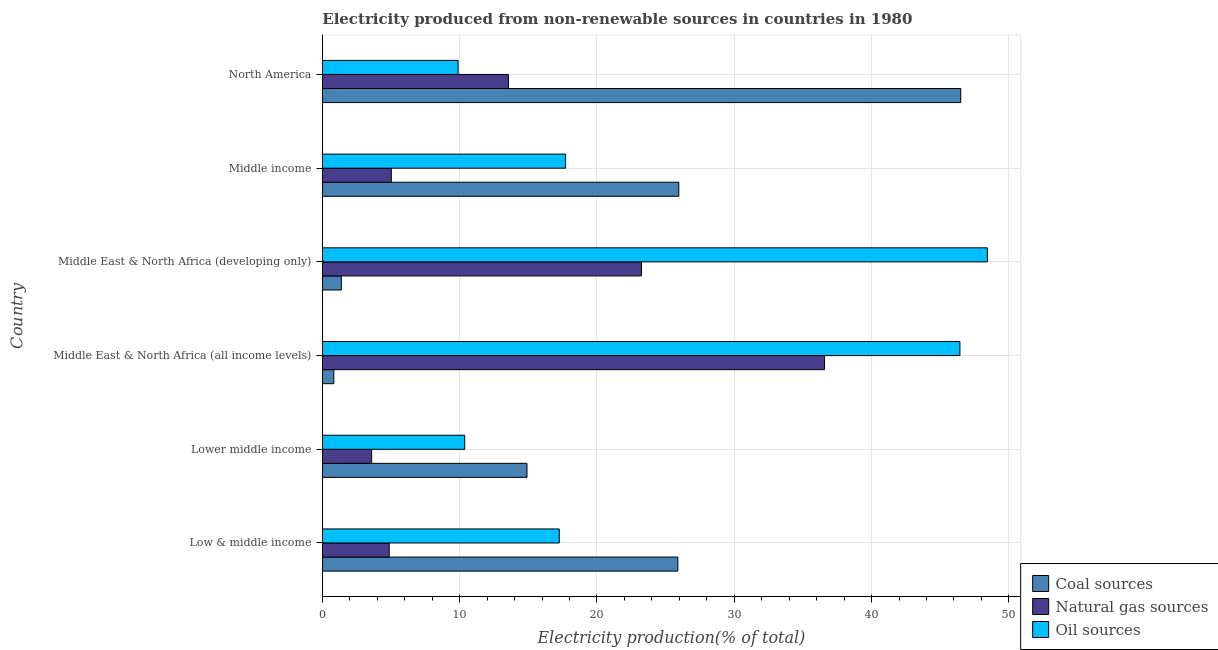How many different coloured bars are there?
Offer a very short reply. 3. Are the number of bars on each tick of the Y-axis equal?
Your response must be concise. Yes. How many bars are there on the 4th tick from the bottom?
Make the answer very short. 3. What is the label of the 6th group of bars from the top?
Give a very brief answer. Low & middle income. In how many cases, is the number of bars for a given country not equal to the number of legend labels?
Offer a terse response. 0. What is the percentage of electricity produced by natural gas in Middle East & North Africa (all income levels)?
Your answer should be very brief. 36.58. Across all countries, what is the maximum percentage of electricity produced by natural gas?
Offer a very short reply. 36.58. Across all countries, what is the minimum percentage of electricity produced by oil sources?
Make the answer very short. 9.89. In which country was the percentage of electricity produced by natural gas maximum?
Make the answer very short. Middle East & North Africa (all income levels). What is the total percentage of electricity produced by coal in the graph?
Your answer should be compact. 115.48. What is the difference between the percentage of electricity produced by coal in Middle East & North Africa (all income levels) and that in Middle income?
Ensure brevity in your answer.  -25.12. What is the difference between the percentage of electricity produced by natural gas in Middle income and the percentage of electricity produced by coal in Lower middle income?
Your answer should be very brief. -9.88. What is the average percentage of electricity produced by natural gas per country?
Your response must be concise. 14.48. What is the difference between the percentage of electricity produced by natural gas and percentage of electricity produced by oil sources in North America?
Keep it short and to the point. 3.66. What is the ratio of the percentage of electricity produced by natural gas in Lower middle income to that in Middle East & North Africa (developing only)?
Provide a short and direct response. 0.15. What is the difference between the highest and the second highest percentage of electricity produced by oil sources?
Your response must be concise. 2. What is the difference between the highest and the lowest percentage of electricity produced by natural gas?
Give a very brief answer. 32.98. Is the sum of the percentage of electricity produced by natural gas in Low & middle income and North America greater than the maximum percentage of electricity produced by coal across all countries?
Give a very brief answer. No. What does the 3rd bar from the top in Lower middle income represents?
Give a very brief answer. Coal sources. What does the 2nd bar from the bottom in Middle East & North Africa (developing only) represents?
Provide a succinct answer. Natural gas sources. Are all the bars in the graph horizontal?
Keep it short and to the point. Yes. How many countries are there in the graph?
Your answer should be compact. 6. Are the values on the major ticks of X-axis written in scientific E-notation?
Your answer should be very brief. No. Does the graph contain grids?
Offer a terse response. Yes. Where does the legend appear in the graph?
Your response must be concise. Bottom right. How many legend labels are there?
Your answer should be compact. 3. How are the legend labels stacked?
Provide a succinct answer. Vertical. What is the title of the graph?
Offer a terse response. Electricity produced from non-renewable sources in countries in 1980. Does "Coal" appear as one of the legend labels in the graph?
Offer a terse response. No. What is the Electricity production(% of total) in Coal sources in Low & middle income?
Provide a succinct answer. 25.89. What is the Electricity production(% of total) of Natural gas sources in Low & middle income?
Make the answer very short. 4.87. What is the Electricity production(% of total) of Oil sources in Low & middle income?
Offer a terse response. 17.26. What is the Electricity production(% of total) of Coal sources in Lower middle income?
Make the answer very short. 14.9. What is the Electricity production(% of total) in Natural gas sources in Lower middle income?
Provide a succinct answer. 3.59. What is the Electricity production(% of total) of Oil sources in Lower middle income?
Provide a succinct answer. 10.37. What is the Electricity production(% of total) in Coal sources in Middle East & North Africa (all income levels)?
Your answer should be very brief. 0.84. What is the Electricity production(% of total) of Natural gas sources in Middle East & North Africa (all income levels)?
Your answer should be compact. 36.58. What is the Electricity production(% of total) in Oil sources in Middle East & North Africa (all income levels)?
Your answer should be very brief. 46.43. What is the Electricity production(% of total) in Coal sources in Middle East & North Africa (developing only)?
Ensure brevity in your answer.  1.39. What is the Electricity production(% of total) in Natural gas sources in Middle East & North Africa (developing only)?
Keep it short and to the point. 23.24. What is the Electricity production(% of total) in Oil sources in Middle East & North Africa (developing only)?
Keep it short and to the point. 48.44. What is the Electricity production(% of total) of Coal sources in Middle income?
Offer a very short reply. 25.96. What is the Electricity production(% of total) in Natural gas sources in Middle income?
Offer a terse response. 5.02. What is the Electricity production(% of total) in Oil sources in Middle income?
Your answer should be compact. 17.72. What is the Electricity production(% of total) in Coal sources in North America?
Provide a succinct answer. 46.49. What is the Electricity production(% of total) of Natural gas sources in North America?
Provide a short and direct response. 13.55. What is the Electricity production(% of total) in Oil sources in North America?
Offer a very short reply. 9.89. Across all countries, what is the maximum Electricity production(% of total) in Coal sources?
Provide a succinct answer. 46.49. Across all countries, what is the maximum Electricity production(% of total) in Natural gas sources?
Your response must be concise. 36.58. Across all countries, what is the maximum Electricity production(% of total) in Oil sources?
Offer a very short reply. 48.44. Across all countries, what is the minimum Electricity production(% of total) in Coal sources?
Make the answer very short. 0.84. Across all countries, what is the minimum Electricity production(% of total) in Natural gas sources?
Give a very brief answer. 3.59. Across all countries, what is the minimum Electricity production(% of total) of Oil sources?
Offer a very short reply. 9.89. What is the total Electricity production(% of total) in Coal sources in the graph?
Keep it short and to the point. 115.48. What is the total Electricity production(% of total) of Natural gas sources in the graph?
Keep it short and to the point. 86.85. What is the total Electricity production(% of total) of Oil sources in the graph?
Your response must be concise. 150.1. What is the difference between the Electricity production(% of total) in Coal sources in Low & middle income and that in Lower middle income?
Give a very brief answer. 10.99. What is the difference between the Electricity production(% of total) of Natural gas sources in Low & middle income and that in Lower middle income?
Your response must be concise. 1.28. What is the difference between the Electricity production(% of total) in Oil sources in Low & middle income and that in Lower middle income?
Your answer should be very brief. 6.89. What is the difference between the Electricity production(% of total) in Coal sources in Low & middle income and that in Middle East & North Africa (all income levels)?
Give a very brief answer. 25.05. What is the difference between the Electricity production(% of total) of Natural gas sources in Low & middle income and that in Middle East & North Africa (all income levels)?
Offer a very short reply. -31.71. What is the difference between the Electricity production(% of total) in Oil sources in Low & middle income and that in Middle East & North Africa (all income levels)?
Your answer should be compact. -29.18. What is the difference between the Electricity production(% of total) of Coal sources in Low & middle income and that in Middle East & North Africa (developing only)?
Give a very brief answer. 24.51. What is the difference between the Electricity production(% of total) of Natural gas sources in Low & middle income and that in Middle East & North Africa (developing only)?
Keep it short and to the point. -18.37. What is the difference between the Electricity production(% of total) of Oil sources in Low & middle income and that in Middle East & North Africa (developing only)?
Offer a terse response. -31.18. What is the difference between the Electricity production(% of total) in Coal sources in Low & middle income and that in Middle income?
Your answer should be compact. -0.07. What is the difference between the Electricity production(% of total) of Natural gas sources in Low & middle income and that in Middle income?
Provide a short and direct response. -0.15. What is the difference between the Electricity production(% of total) of Oil sources in Low & middle income and that in Middle income?
Offer a very short reply. -0.46. What is the difference between the Electricity production(% of total) in Coal sources in Low & middle income and that in North America?
Ensure brevity in your answer.  -20.6. What is the difference between the Electricity production(% of total) of Natural gas sources in Low & middle income and that in North America?
Offer a very short reply. -8.68. What is the difference between the Electricity production(% of total) in Oil sources in Low & middle income and that in North America?
Give a very brief answer. 7.37. What is the difference between the Electricity production(% of total) of Coal sources in Lower middle income and that in Middle East & North Africa (all income levels)?
Offer a very short reply. 14.07. What is the difference between the Electricity production(% of total) of Natural gas sources in Lower middle income and that in Middle East & North Africa (all income levels)?
Your answer should be compact. -32.98. What is the difference between the Electricity production(% of total) in Oil sources in Lower middle income and that in Middle East & North Africa (all income levels)?
Provide a succinct answer. -36.06. What is the difference between the Electricity production(% of total) in Coal sources in Lower middle income and that in Middle East & North Africa (developing only)?
Your response must be concise. 13.52. What is the difference between the Electricity production(% of total) in Natural gas sources in Lower middle income and that in Middle East & North Africa (developing only)?
Give a very brief answer. -19.65. What is the difference between the Electricity production(% of total) of Oil sources in Lower middle income and that in Middle East & North Africa (developing only)?
Keep it short and to the point. -38.07. What is the difference between the Electricity production(% of total) of Coal sources in Lower middle income and that in Middle income?
Keep it short and to the point. -11.06. What is the difference between the Electricity production(% of total) of Natural gas sources in Lower middle income and that in Middle income?
Offer a terse response. -1.43. What is the difference between the Electricity production(% of total) of Oil sources in Lower middle income and that in Middle income?
Your answer should be compact. -7.35. What is the difference between the Electricity production(% of total) in Coal sources in Lower middle income and that in North America?
Your response must be concise. -31.59. What is the difference between the Electricity production(% of total) in Natural gas sources in Lower middle income and that in North America?
Make the answer very short. -9.96. What is the difference between the Electricity production(% of total) of Oil sources in Lower middle income and that in North America?
Your response must be concise. 0.48. What is the difference between the Electricity production(% of total) of Coal sources in Middle East & North Africa (all income levels) and that in Middle East & North Africa (developing only)?
Offer a terse response. -0.55. What is the difference between the Electricity production(% of total) of Natural gas sources in Middle East & North Africa (all income levels) and that in Middle East & North Africa (developing only)?
Provide a short and direct response. 13.34. What is the difference between the Electricity production(% of total) of Oil sources in Middle East & North Africa (all income levels) and that in Middle East & North Africa (developing only)?
Ensure brevity in your answer.  -2. What is the difference between the Electricity production(% of total) of Coal sources in Middle East & North Africa (all income levels) and that in Middle income?
Your answer should be compact. -25.12. What is the difference between the Electricity production(% of total) of Natural gas sources in Middle East & North Africa (all income levels) and that in Middle income?
Ensure brevity in your answer.  31.55. What is the difference between the Electricity production(% of total) of Oil sources in Middle East & North Africa (all income levels) and that in Middle income?
Your answer should be very brief. 28.72. What is the difference between the Electricity production(% of total) in Coal sources in Middle East & North Africa (all income levels) and that in North America?
Offer a very short reply. -45.66. What is the difference between the Electricity production(% of total) of Natural gas sources in Middle East & North Africa (all income levels) and that in North America?
Your answer should be compact. 23.03. What is the difference between the Electricity production(% of total) of Oil sources in Middle East & North Africa (all income levels) and that in North America?
Your answer should be compact. 36.55. What is the difference between the Electricity production(% of total) of Coal sources in Middle East & North Africa (developing only) and that in Middle income?
Give a very brief answer. -24.58. What is the difference between the Electricity production(% of total) in Natural gas sources in Middle East & North Africa (developing only) and that in Middle income?
Provide a short and direct response. 18.22. What is the difference between the Electricity production(% of total) in Oil sources in Middle East & North Africa (developing only) and that in Middle income?
Make the answer very short. 30.72. What is the difference between the Electricity production(% of total) of Coal sources in Middle East & North Africa (developing only) and that in North America?
Offer a terse response. -45.11. What is the difference between the Electricity production(% of total) of Natural gas sources in Middle East & North Africa (developing only) and that in North America?
Provide a short and direct response. 9.69. What is the difference between the Electricity production(% of total) of Oil sources in Middle East & North Africa (developing only) and that in North America?
Ensure brevity in your answer.  38.55. What is the difference between the Electricity production(% of total) of Coal sources in Middle income and that in North America?
Make the answer very short. -20.53. What is the difference between the Electricity production(% of total) of Natural gas sources in Middle income and that in North America?
Provide a succinct answer. -8.53. What is the difference between the Electricity production(% of total) in Oil sources in Middle income and that in North America?
Make the answer very short. 7.83. What is the difference between the Electricity production(% of total) of Coal sources in Low & middle income and the Electricity production(% of total) of Natural gas sources in Lower middle income?
Give a very brief answer. 22.3. What is the difference between the Electricity production(% of total) in Coal sources in Low & middle income and the Electricity production(% of total) in Oil sources in Lower middle income?
Offer a terse response. 15.52. What is the difference between the Electricity production(% of total) of Natural gas sources in Low & middle income and the Electricity production(% of total) of Oil sources in Lower middle income?
Your response must be concise. -5.5. What is the difference between the Electricity production(% of total) in Coal sources in Low & middle income and the Electricity production(% of total) in Natural gas sources in Middle East & North Africa (all income levels)?
Your answer should be very brief. -10.68. What is the difference between the Electricity production(% of total) of Coal sources in Low & middle income and the Electricity production(% of total) of Oil sources in Middle East & North Africa (all income levels)?
Offer a very short reply. -20.54. What is the difference between the Electricity production(% of total) of Natural gas sources in Low & middle income and the Electricity production(% of total) of Oil sources in Middle East & North Africa (all income levels)?
Your answer should be compact. -41.56. What is the difference between the Electricity production(% of total) in Coal sources in Low & middle income and the Electricity production(% of total) in Natural gas sources in Middle East & North Africa (developing only)?
Provide a succinct answer. 2.65. What is the difference between the Electricity production(% of total) in Coal sources in Low & middle income and the Electricity production(% of total) in Oil sources in Middle East & North Africa (developing only)?
Keep it short and to the point. -22.54. What is the difference between the Electricity production(% of total) in Natural gas sources in Low & middle income and the Electricity production(% of total) in Oil sources in Middle East & North Africa (developing only)?
Offer a very short reply. -43.56. What is the difference between the Electricity production(% of total) of Coal sources in Low & middle income and the Electricity production(% of total) of Natural gas sources in Middle income?
Provide a short and direct response. 20.87. What is the difference between the Electricity production(% of total) in Coal sources in Low & middle income and the Electricity production(% of total) in Oil sources in Middle income?
Ensure brevity in your answer.  8.17. What is the difference between the Electricity production(% of total) in Natural gas sources in Low & middle income and the Electricity production(% of total) in Oil sources in Middle income?
Make the answer very short. -12.85. What is the difference between the Electricity production(% of total) of Coal sources in Low & middle income and the Electricity production(% of total) of Natural gas sources in North America?
Keep it short and to the point. 12.34. What is the difference between the Electricity production(% of total) in Coal sources in Low & middle income and the Electricity production(% of total) in Oil sources in North America?
Your response must be concise. 16.01. What is the difference between the Electricity production(% of total) of Natural gas sources in Low & middle income and the Electricity production(% of total) of Oil sources in North America?
Ensure brevity in your answer.  -5.02. What is the difference between the Electricity production(% of total) of Coal sources in Lower middle income and the Electricity production(% of total) of Natural gas sources in Middle East & North Africa (all income levels)?
Your response must be concise. -21.67. What is the difference between the Electricity production(% of total) of Coal sources in Lower middle income and the Electricity production(% of total) of Oil sources in Middle East & North Africa (all income levels)?
Your response must be concise. -31.53. What is the difference between the Electricity production(% of total) of Natural gas sources in Lower middle income and the Electricity production(% of total) of Oil sources in Middle East & North Africa (all income levels)?
Your response must be concise. -42.84. What is the difference between the Electricity production(% of total) of Coal sources in Lower middle income and the Electricity production(% of total) of Natural gas sources in Middle East & North Africa (developing only)?
Ensure brevity in your answer.  -8.34. What is the difference between the Electricity production(% of total) in Coal sources in Lower middle income and the Electricity production(% of total) in Oil sources in Middle East & North Africa (developing only)?
Ensure brevity in your answer.  -33.53. What is the difference between the Electricity production(% of total) of Natural gas sources in Lower middle income and the Electricity production(% of total) of Oil sources in Middle East & North Africa (developing only)?
Provide a short and direct response. -44.84. What is the difference between the Electricity production(% of total) of Coal sources in Lower middle income and the Electricity production(% of total) of Natural gas sources in Middle income?
Make the answer very short. 9.88. What is the difference between the Electricity production(% of total) of Coal sources in Lower middle income and the Electricity production(% of total) of Oil sources in Middle income?
Provide a succinct answer. -2.81. What is the difference between the Electricity production(% of total) of Natural gas sources in Lower middle income and the Electricity production(% of total) of Oil sources in Middle income?
Make the answer very short. -14.12. What is the difference between the Electricity production(% of total) of Coal sources in Lower middle income and the Electricity production(% of total) of Natural gas sources in North America?
Provide a succinct answer. 1.35. What is the difference between the Electricity production(% of total) in Coal sources in Lower middle income and the Electricity production(% of total) in Oil sources in North America?
Provide a short and direct response. 5.02. What is the difference between the Electricity production(% of total) of Natural gas sources in Lower middle income and the Electricity production(% of total) of Oil sources in North America?
Provide a short and direct response. -6.29. What is the difference between the Electricity production(% of total) of Coal sources in Middle East & North Africa (all income levels) and the Electricity production(% of total) of Natural gas sources in Middle East & North Africa (developing only)?
Keep it short and to the point. -22.4. What is the difference between the Electricity production(% of total) in Coal sources in Middle East & North Africa (all income levels) and the Electricity production(% of total) in Oil sources in Middle East & North Africa (developing only)?
Offer a terse response. -47.6. What is the difference between the Electricity production(% of total) in Natural gas sources in Middle East & North Africa (all income levels) and the Electricity production(% of total) in Oil sources in Middle East & North Africa (developing only)?
Your answer should be very brief. -11.86. What is the difference between the Electricity production(% of total) in Coal sources in Middle East & North Africa (all income levels) and the Electricity production(% of total) in Natural gas sources in Middle income?
Offer a very short reply. -4.18. What is the difference between the Electricity production(% of total) of Coal sources in Middle East & North Africa (all income levels) and the Electricity production(% of total) of Oil sources in Middle income?
Keep it short and to the point. -16.88. What is the difference between the Electricity production(% of total) in Natural gas sources in Middle East & North Africa (all income levels) and the Electricity production(% of total) in Oil sources in Middle income?
Your answer should be compact. 18.86. What is the difference between the Electricity production(% of total) in Coal sources in Middle East & North Africa (all income levels) and the Electricity production(% of total) in Natural gas sources in North America?
Offer a very short reply. -12.71. What is the difference between the Electricity production(% of total) in Coal sources in Middle East & North Africa (all income levels) and the Electricity production(% of total) in Oil sources in North America?
Your response must be concise. -9.05. What is the difference between the Electricity production(% of total) in Natural gas sources in Middle East & North Africa (all income levels) and the Electricity production(% of total) in Oil sources in North America?
Your answer should be very brief. 26.69. What is the difference between the Electricity production(% of total) in Coal sources in Middle East & North Africa (developing only) and the Electricity production(% of total) in Natural gas sources in Middle income?
Your answer should be compact. -3.64. What is the difference between the Electricity production(% of total) of Coal sources in Middle East & North Africa (developing only) and the Electricity production(% of total) of Oil sources in Middle income?
Provide a short and direct response. -16.33. What is the difference between the Electricity production(% of total) in Natural gas sources in Middle East & North Africa (developing only) and the Electricity production(% of total) in Oil sources in Middle income?
Your response must be concise. 5.52. What is the difference between the Electricity production(% of total) in Coal sources in Middle East & North Africa (developing only) and the Electricity production(% of total) in Natural gas sources in North America?
Provide a succinct answer. -12.17. What is the difference between the Electricity production(% of total) of Coal sources in Middle East & North Africa (developing only) and the Electricity production(% of total) of Oil sources in North America?
Provide a succinct answer. -8.5. What is the difference between the Electricity production(% of total) of Natural gas sources in Middle East & North Africa (developing only) and the Electricity production(% of total) of Oil sources in North America?
Your answer should be very brief. 13.35. What is the difference between the Electricity production(% of total) of Coal sources in Middle income and the Electricity production(% of total) of Natural gas sources in North America?
Your answer should be very brief. 12.41. What is the difference between the Electricity production(% of total) in Coal sources in Middle income and the Electricity production(% of total) in Oil sources in North America?
Your answer should be compact. 16.07. What is the difference between the Electricity production(% of total) of Natural gas sources in Middle income and the Electricity production(% of total) of Oil sources in North America?
Offer a very short reply. -4.86. What is the average Electricity production(% of total) of Coal sources per country?
Your answer should be very brief. 19.25. What is the average Electricity production(% of total) of Natural gas sources per country?
Give a very brief answer. 14.48. What is the average Electricity production(% of total) of Oil sources per country?
Your answer should be compact. 25.02. What is the difference between the Electricity production(% of total) of Coal sources and Electricity production(% of total) of Natural gas sources in Low & middle income?
Provide a short and direct response. 21.02. What is the difference between the Electricity production(% of total) of Coal sources and Electricity production(% of total) of Oil sources in Low & middle income?
Offer a very short reply. 8.64. What is the difference between the Electricity production(% of total) in Natural gas sources and Electricity production(% of total) in Oil sources in Low & middle income?
Provide a short and direct response. -12.38. What is the difference between the Electricity production(% of total) of Coal sources and Electricity production(% of total) of Natural gas sources in Lower middle income?
Offer a very short reply. 11.31. What is the difference between the Electricity production(% of total) of Coal sources and Electricity production(% of total) of Oil sources in Lower middle income?
Provide a succinct answer. 4.53. What is the difference between the Electricity production(% of total) in Natural gas sources and Electricity production(% of total) in Oil sources in Lower middle income?
Offer a terse response. -6.78. What is the difference between the Electricity production(% of total) in Coal sources and Electricity production(% of total) in Natural gas sources in Middle East & North Africa (all income levels)?
Ensure brevity in your answer.  -35.74. What is the difference between the Electricity production(% of total) in Coal sources and Electricity production(% of total) in Oil sources in Middle East & North Africa (all income levels)?
Give a very brief answer. -45.6. What is the difference between the Electricity production(% of total) of Natural gas sources and Electricity production(% of total) of Oil sources in Middle East & North Africa (all income levels)?
Your response must be concise. -9.86. What is the difference between the Electricity production(% of total) in Coal sources and Electricity production(% of total) in Natural gas sources in Middle East & North Africa (developing only)?
Your response must be concise. -21.86. What is the difference between the Electricity production(% of total) in Coal sources and Electricity production(% of total) in Oil sources in Middle East & North Africa (developing only)?
Offer a very short reply. -47.05. What is the difference between the Electricity production(% of total) in Natural gas sources and Electricity production(% of total) in Oil sources in Middle East & North Africa (developing only)?
Your response must be concise. -25.19. What is the difference between the Electricity production(% of total) in Coal sources and Electricity production(% of total) in Natural gas sources in Middle income?
Provide a succinct answer. 20.94. What is the difference between the Electricity production(% of total) in Coal sources and Electricity production(% of total) in Oil sources in Middle income?
Make the answer very short. 8.24. What is the difference between the Electricity production(% of total) of Natural gas sources and Electricity production(% of total) of Oil sources in Middle income?
Provide a short and direct response. -12.69. What is the difference between the Electricity production(% of total) in Coal sources and Electricity production(% of total) in Natural gas sources in North America?
Ensure brevity in your answer.  32.94. What is the difference between the Electricity production(% of total) of Coal sources and Electricity production(% of total) of Oil sources in North America?
Offer a very short reply. 36.61. What is the difference between the Electricity production(% of total) of Natural gas sources and Electricity production(% of total) of Oil sources in North America?
Your answer should be compact. 3.66. What is the ratio of the Electricity production(% of total) in Coal sources in Low & middle income to that in Lower middle income?
Make the answer very short. 1.74. What is the ratio of the Electricity production(% of total) in Natural gas sources in Low & middle income to that in Lower middle income?
Your answer should be compact. 1.36. What is the ratio of the Electricity production(% of total) of Oil sources in Low & middle income to that in Lower middle income?
Your answer should be very brief. 1.66. What is the ratio of the Electricity production(% of total) of Coal sources in Low & middle income to that in Middle East & North Africa (all income levels)?
Offer a terse response. 30.9. What is the ratio of the Electricity production(% of total) of Natural gas sources in Low & middle income to that in Middle East & North Africa (all income levels)?
Your answer should be compact. 0.13. What is the ratio of the Electricity production(% of total) in Oil sources in Low & middle income to that in Middle East & North Africa (all income levels)?
Your response must be concise. 0.37. What is the ratio of the Electricity production(% of total) in Coal sources in Low & middle income to that in Middle East & North Africa (developing only)?
Offer a terse response. 18.69. What is the ratio of the Electricity production(% of total) of Natural gas sources in Low & middle income to that in Middle East & North Africa (developing only)?
Offer a terse response. 0.21. What is the ratio of the Electricity production(% of total) of Oil sources in Low & middle income to that in Middle East & North Africa (developing only)?
Offer a terse response. 0.36. What is the ratio of the Electricity production(% of total) of Coal sources in Low & middle income to that in Middle income?
Your response must be concise. 1. What is the ratio of the Electricity production(% of total) of Natural gas sources in Low & middle income to that in Middle income?
Make the answer very short. 0.97. What is the ratio of the Electricity production(% of total) in Oil sources in Low & middle income to that in Middle income?
Give a very brief answer. 0.97. What is the ratio of the Electricity production(% of total) in Coal sources in Low & middle income to that in North America?
Ensure brevity in your answer.  0.56. What is the ratio of the Electricity production(% of total) of Natural gas sources in Low & middle income to that in North America?
Your answer should be very brief. 0.36. What is the ratio of the Electricity production(% of total) of Oil sources in Low & middle income to that in North America?
Your answer should be compact. 1.75. What is the ratio of the Electricity production(% of total) of Coal sources in Lower middle income to that in Middle East & North Africa (all income levels)?
Provide a succinct answer. 17.79. What is the ratio of the Electricity production(% of total) in Natural gas sources in Lower middle income to that in Middle East & North Africa (all income levels)?
Your response must be concise. 0.1. What is the ratio of the Electricity production(% of total) in Oil sources in Lower middle income to that in Middle East & North Africa (all income levels)?
Provide a succinct answer. 0.22. What is the ratio of the Electricity production(% of total) of Coal sources in Lower middle income to that in Middle East & North Africa (developing only)?
Provide a short and direct response. 10.76. What is the ratio of the Electricity production(% of total) in Natural gas sources in Lower middle income to that in Middle East & North Africa (developing only)?
Make the answer very short. 0.15. What is the ratio of the Electricity production(% of total) in Oil sources in Lower middle income to that in Middle East & North Africa (developing only)?
Offer a terse response. 0.21. What is the ratio of the Electricity production(% of total) of Coal sources in Lower middle income to that in Middle income?
Give a very brief answer. 0.57. What is the ratio of the Electricity production(% of total) in Natural gas sources in Lower middle income to that in Middle income?
Offer a very short reply. 0.72. What is the ratio of the Electricity production(% of total) of Oil sources in Lower middle income to that in Middle income?
Give a very brief answer. 0.59. What is the ratio of the Electricity production(% of total) of Coal sources in Lower middle income to that in North America?
Give a very brief answer. 0.32. What is the ratio of the Electricity production(% of total) of Natural gas sources in Lower middle income to that in North America?
Provide a succinct answer. 0.27. What is the ratio of the Electricity production(% of total) in Oil sources in Lower middle income to that in North America?
Offer a very short reply. 1.05. What is the ratio of the Electricity production(% of total) of Coal sources in Middle East & North Africa (all income levels) to that in Middle East & North Africa (developing only)?
Provide a short and direct response. 0.6. What is the ratio of the Electricity production(% of total) in Natural gas sources in Middle East & North Africa (all income levels) to that in Middle East & North Africa (developing only)?
Offer a terse response. 1.57. What is the ratio of the Electricity production(% of total) of Oil sources in Middle East & North Africa (all income levels) to that in Middle East & North Africa (developing only)?
Provide a succinct answer. 0.96. What is the ratio of the Electricity production(% of total) of Coal sources in Middle East & North Africa (all income levels) to that in Middle income?
Your answer should be very brief. 0.03. What is the ratio of the Electricity production(% of total) of Natural gas sources in Middle East & North Africa (all income levels) to that in Middle income?
Give a very brief answer. 7.28. What is the ratio of the Electricity production(% of total) of Oil sources in Middle East & North Africa (all income levels) to that in Middle income?
Make the answer very short. 2.62. What is the ratio of the Electricity production(% of total) in Coal sources in Middle East & North Africa (all income levels) to that in North America?
Provide a succinct answer. 0.02. What is the ratio of the Electricity production(% of total) in Natural gas sources in Middle East & North Africa (all income levels) to that in North America?
Provide a succinct answer. 2.7. What is the ratio of the Electricity production(% of total) in Oil sources in Middle East & North Africa (all income levels) to that in North America?
Your answer should be very brief. 4.7. What is the ratio of the Electricity production(% of total) in Coal sources in Middle East & North Africa (developing only) to that in Middle income?
Give a very brief answer. 0.05. What is the ratio of the Electricity production(% of total) of Natural gas sources in Middle East & North Africa (developing only) to that in Middle income?
Keep it short and to the point. 4.63. What is the ratio of the Electricity production(% of total) of Oil sources in Middle East & North Africa (developing only) to that in Middle income?
Your answer should be compact. 2.73. What is the ratio of the Electricity production(% of total) in Coal sources in Middle East & North Africa (developing only) to that in North America?
Your answer should be very brief. 0.03. What is the ratio of the Electricity production(% of total) in Natural gas sources in Middle East & North Africa (developing only) to that in North America?
Ensure brevity in your answer.  1.72. What is the ratio of the Electricity production(% of total) in Oil sources in Middle East & North Africa (developing only) to that in North America?
Your response must be concise. 4.9. What is the ratio of the Electricity production(% of total) in Coal sources in Middle income to that in North America?
Provide a succinct answer. 0.56. What is the ratio of the Electricity production(% of total) in Natural gas sources in Middle income to that in North America?
Give a very brief answer. 0.37. What is the ratio of the Electricity production(% of total) in Oil sources in Middle income to that in North America?
Provide a short and direct response. 1.79. What is the difference between the highest and the second highest Electricity production(% of total) in Coal sources?
Ensure brevity in your answer.  20.53. What is the difference between the highest and the second highest Electricity production(% of total) in Natural gas sources?
Your answer should be very brief. 13.34. What is the difference between the highest and the second highest Electricity production(% of total) of Oil sources?
Make the answer very short. 2. What is the difference between the highest and the lowest Electricity production(% of total) in Coal sources?
Give a very brief answer. 45.66. What is the difference between the highest and the lowest Electricity production(% of total) in Natural gas sources?
Provide a short and direct response. 32.98. What is the difference between the highest and the lowest Electricity production(% of total) of Oil sources?
Your response must be concise. 38.55. 